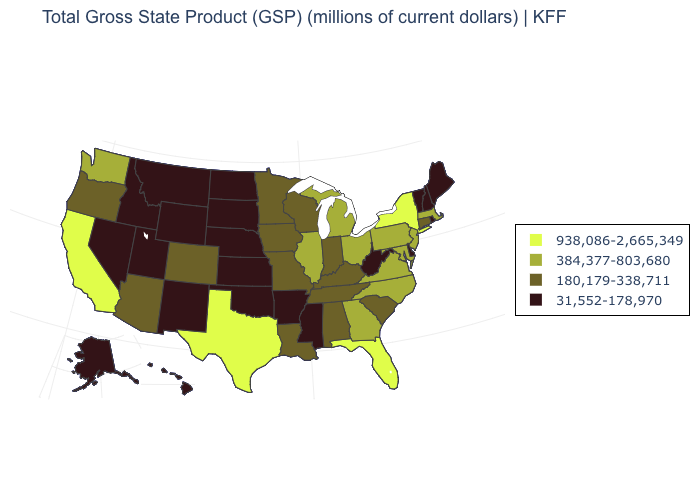What is the value of South Carolina?
Keep it brief. 180,179-338,711. What is the value of Nebraska?
Write a very short answer. 31,552-178,970. Does the map have missing data?
Short answer required. No. Name the states that have a value in the range 938,086-2,665,349?
Give a very brief answer. California, Florida, New York, Texas. What is the lowest value in states that border Indiana?
Quick response, please. 180,179-338,711. Which states have the lowest value in the USA?
Keep it brief. Alaska, Arkansas, Delaware, Hawaii, Idaho, Kansas, Maine, Mississippi, Montana, Nebraska, Nevada, New Hampshire, New Mexico, North Dakota, Oklahoma, Rhode Island, South Dakota, Utah, Vermont, West Virginia, Wyoming. Does Mississippi have the lowest value in the South?
Be succinct. Yes. Which states hav the highest value in the West?
Quick response, please. California. What is the value of Utah?
Short answer required. 31,552-178,970. Which states have the highest value in the USA?
Quick response, please. California, Florida, New York, Texas. Does Alabama have a lower value than Florida?
Keep it brief. Yes. What is the value of Wisconsin?
Keep it brief. 180,179-338,711. Among the states that border Montana , which have the highest value?
Give a very brief answer. Idaho, North Dakota, South Dakota, Wyoming. What is the lowest value in states that border South Dakota?
Write a very short answer. 31,552-178,970. Name the states that have a value in the range 31,552-178,970?
Be succinct. Alaska, Arkansas, Delaware, Hawaii, Idaho, Kansas, Maine, Mississippi, Montana, Nebraska, Nevada, New Hampshire, New Mexico, North Dakota, Oklahoma, Rhode Island, South Dakota, Utah, Vermont, West Virginia, Wyoming. 